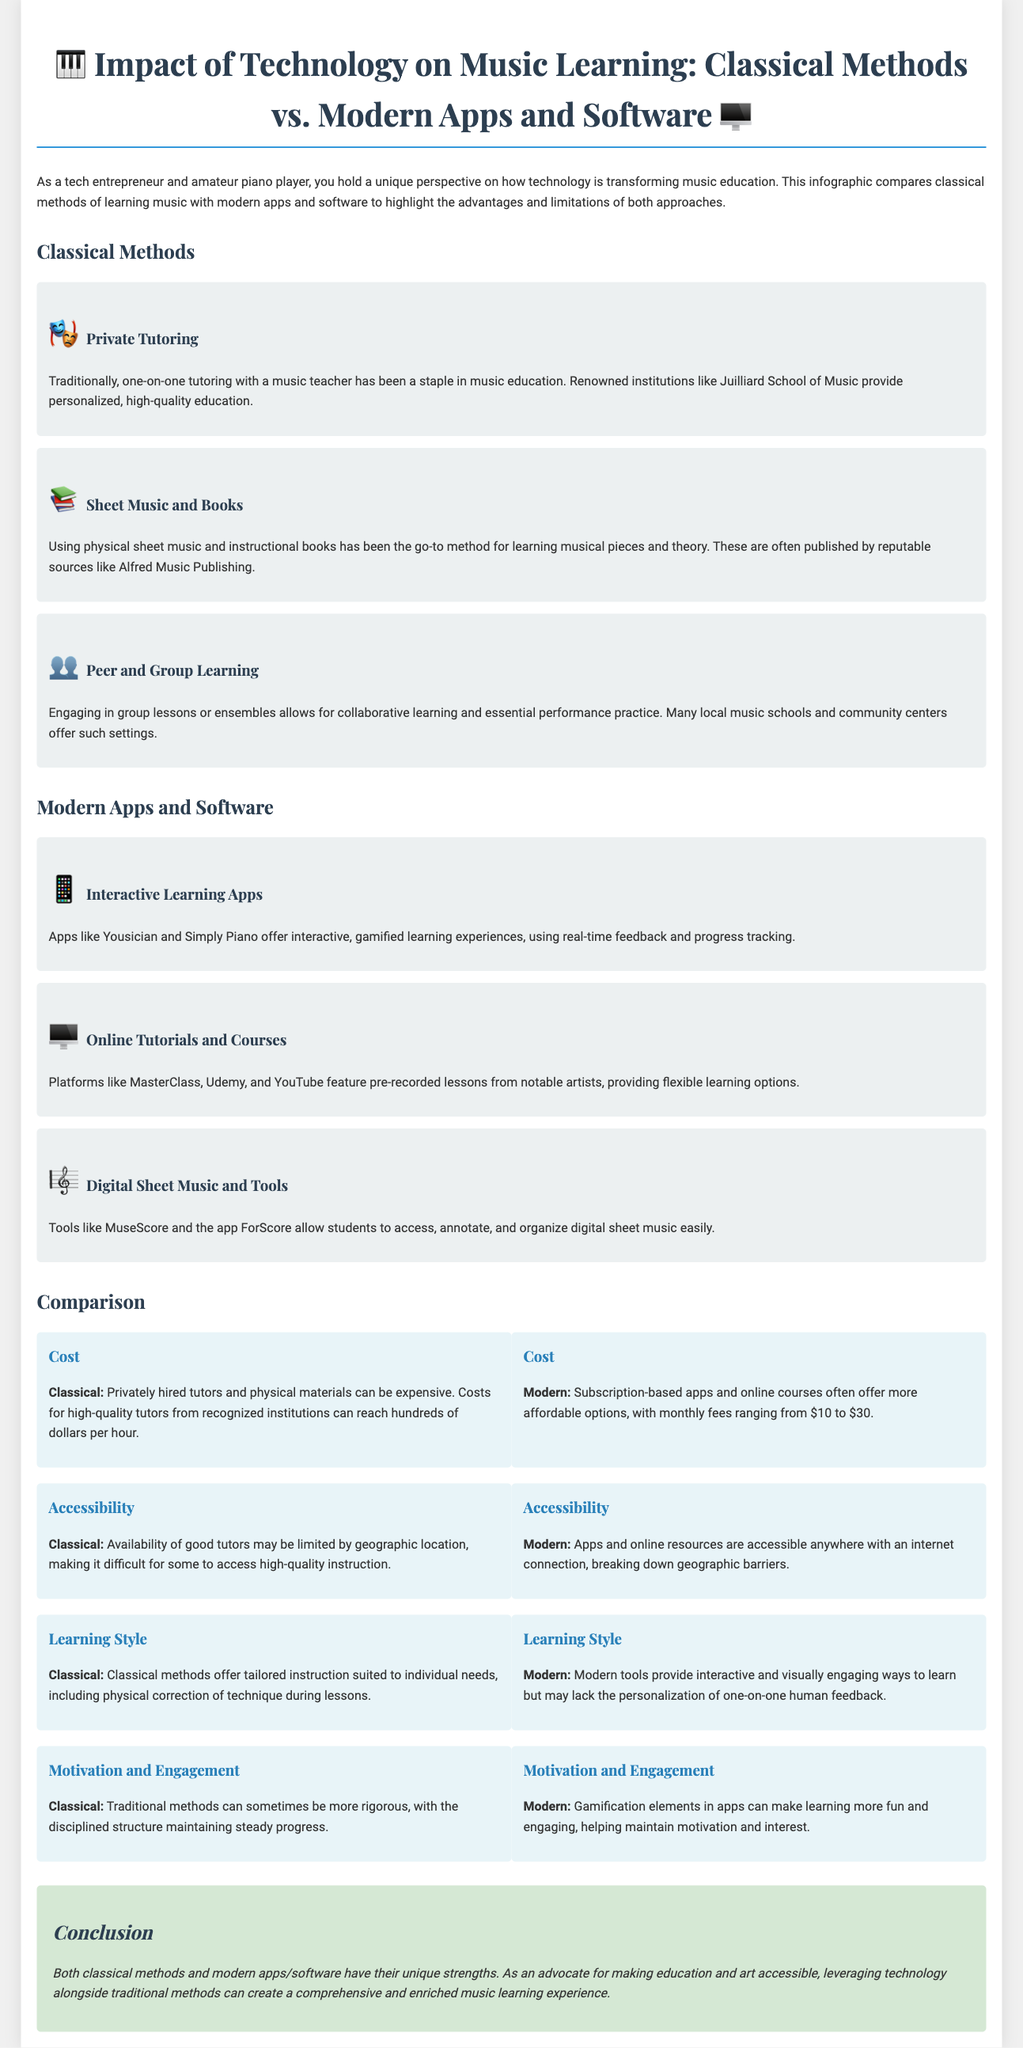What is a common method of music education mentioned? The document highlights private tutoring as a common classical method of music education.
Answer: Private Tutoring Which institution is recognized for its quality music education? The Juilliard School of Music is mentioned as a renowned institution providing high-quality education.
Answer: Juilliard School of Music What is the typical cost range for modern learning apps? The document states that modern apps often have monthly fees ranging from $10 to $30.
Answer: $10 to $30 Which method offers tailored instruction suited to individual needs? The comparison shows that classical methods offer tailored instruction.
Answer: Classical methods What is a key advantage of modern apps regarding accessibility? The document points out that modern apps are accessible anywhere with an internet connection.
Answer: Accessible anywhere with an internet connection Which learning method is associated with gamification for motivation? The document indicates that modern tools use gamification to enhance motivation and engagement.
Answer: Modern apps How does the rigidity of classical methods impact progress? The document suggests that traditional methods can maintain steady progress due to their disciplined structure.
Answer: Steady progress What type of resources do online tutorials provide? The document specifies that online tutorials offer pre-recorded lessons from notable artists.
Answer: Pre-recorded lessons What conclusion does the document draw about combining both methods? It suggests that leveraging technology alongside traditional methods enriches the music learning experience.
Answer: Enriched music learning experience 